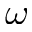Convert formula to latex. <formula><loc_0><loc_0><loc_500><loc_500>\omega</formula> 